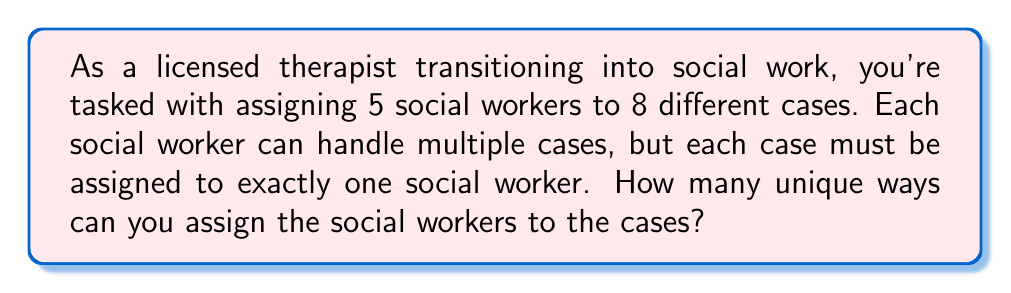Solve this math problem. To solve this problem, we need to use the concept of combinations with repetition. Here's why:

1. We have 5 social workers (choices) for each of the 8 cases.
2. The order of assignment doesn't matter (e.g., assigning Worker A to Case 1 and Worker B to Case 2 is the same as assigning Worker B to Case 1 and Worker A to Case 2).
3. We can reuse social workers (they can be assigned to multiple cases).

The formula for combinations with repetition is:

$$ \binom{n+r-1}{r} = \binom{n+r-1}{n-1} $$

Where:
$n$ = number of choices (social workers)
$r$ = number of selections (cases)

In our problem:
$n = 5$ (social workers)
$r = 8$ (cases)

Plugging these values into the formula:

$$ \binom{5+8-1}{8} = \binom{12}{8} $$

To calculate this:

$$ \binom{12}{8} = \frac{12!}{8!(12-8)!} = \frac{12!}{8!4!} $$

$$ = \frac{12 \times 11 \times 10 \times 9}{4 \times 3 \times 2 \times 1} = 495 $$

Therefore, there are 495 unique ways to assign the social workers to the cases.
Answer: 495 